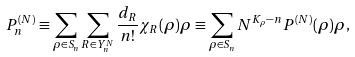<formula> <loc_0><loc_0><loc_500><loc_500>P _ { n } ^ { ( N ) } \equiv \sum _ { \rho \in S _ { n } } \sum _ { R \in Y _ { n } ^ { N } } \frac { d _ { R } } { n ! } \chi _ { R } ( \rho ) \rho \equiv \sum _ { \rho \in S _ { n } } N ^ { K _ { \rho } - n } P ^ { ( N ) } ( \rho ) \rho ,</formula> 